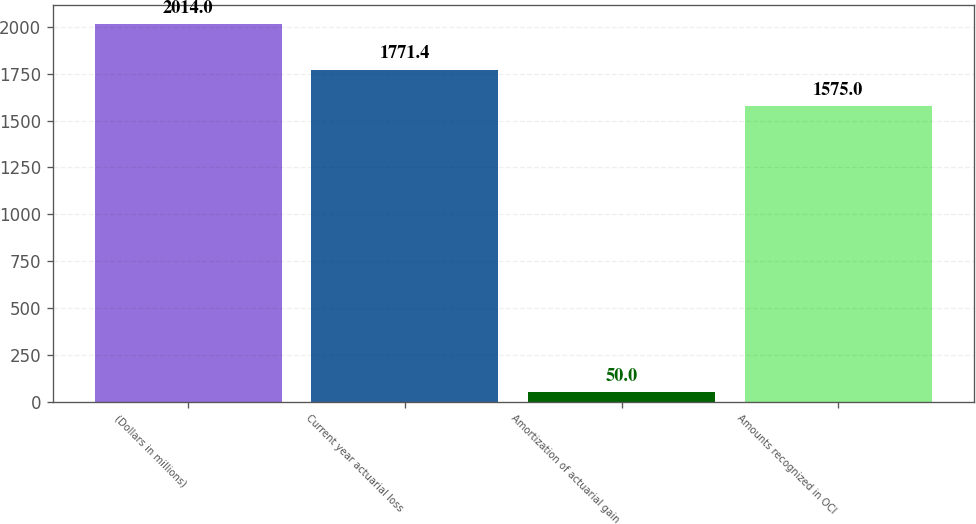<chart> <loc_0><loc_0><loc_500><loc_500><bar_chart><fcel>(Dollars in millions)<fcel>Current year actuarial loss<fcel>Amortization of actuarial gain<fcel>Amounts recognized in OCI<nl><fcel>2014<fcel>1771.4<fcel>50<fcel>1575<nl></chart> 